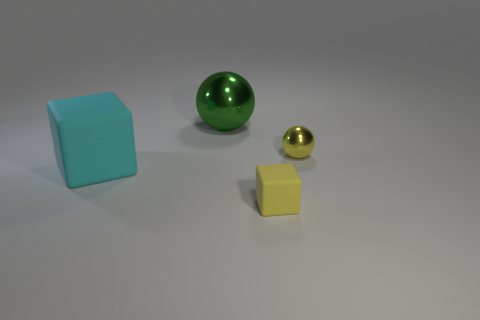Subtract all yellow spheres. How many spheres are left? 1 Add 1 objects. How many objects exist? 5 Subtract all purple balls. Subtract all blue cubes. How many balls are left? 2 Subtract all red balls. How many green cubes are left? 0 Subtract all brown metal cylinders. Subtract all tiny yellow rubber blocks. How many objects are left? 3 Add 3 large things. How many large things are left? 5 Add 4 big green balls. How many big green balls exist? 5 Subtract 0 green cylinders. How many objects are left? 4 